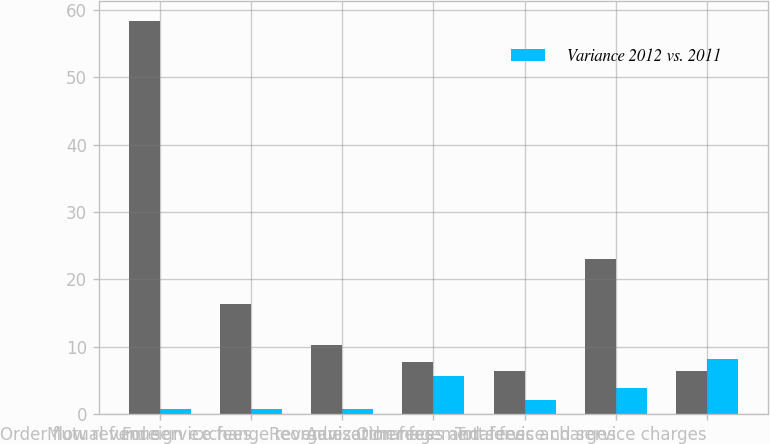Convert chart. <chart><loc_0><loc_0><loc_500><loc_500><stacked_bar_chart><ecel><fcel>Order flow revenue<fcel>Mutual fund service fees<fcel>Foreign exchange revenue<fcel>Reorganization fees<fcel>Advisor management fees<fcel>Other fees and service charges<fcel>Total fees and service charges<nl><fcel>nan<fcel>58.4<fcel>16.4<fcel>10.3<fcel>7.7<fcel>6.4<fcel>23<fcel>6.4<nl><fcel>Variance 2012 vs. 2011<fcel>0.7<fcel>0.7<fcel>0.7<fcel>5.7<fcel>2<fcel>3.8<fcel>8.2<nl></chart> 